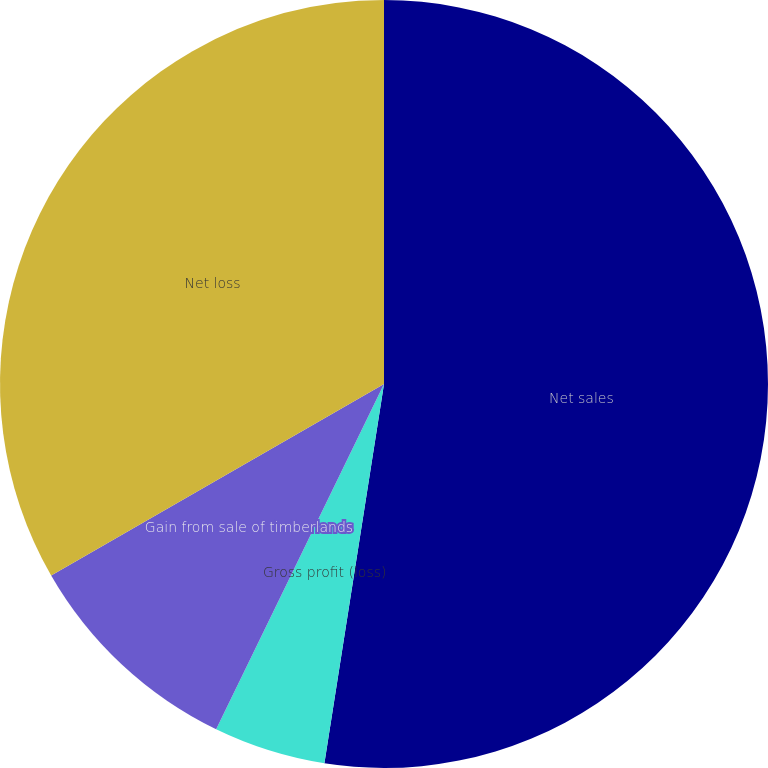Convert chart to OTSL. <chart><loc_0><loc_0><loc_500><loc_500><pie_chart><fcel>Net sales<fcel>Gross profit (loss)<fcel>Gain from sale of timberlands<fcel>Net loss<nl><fcel>52.48%<fcel>4.72%<fcel>9.49%<fcel>33.31%<nl></chart> 